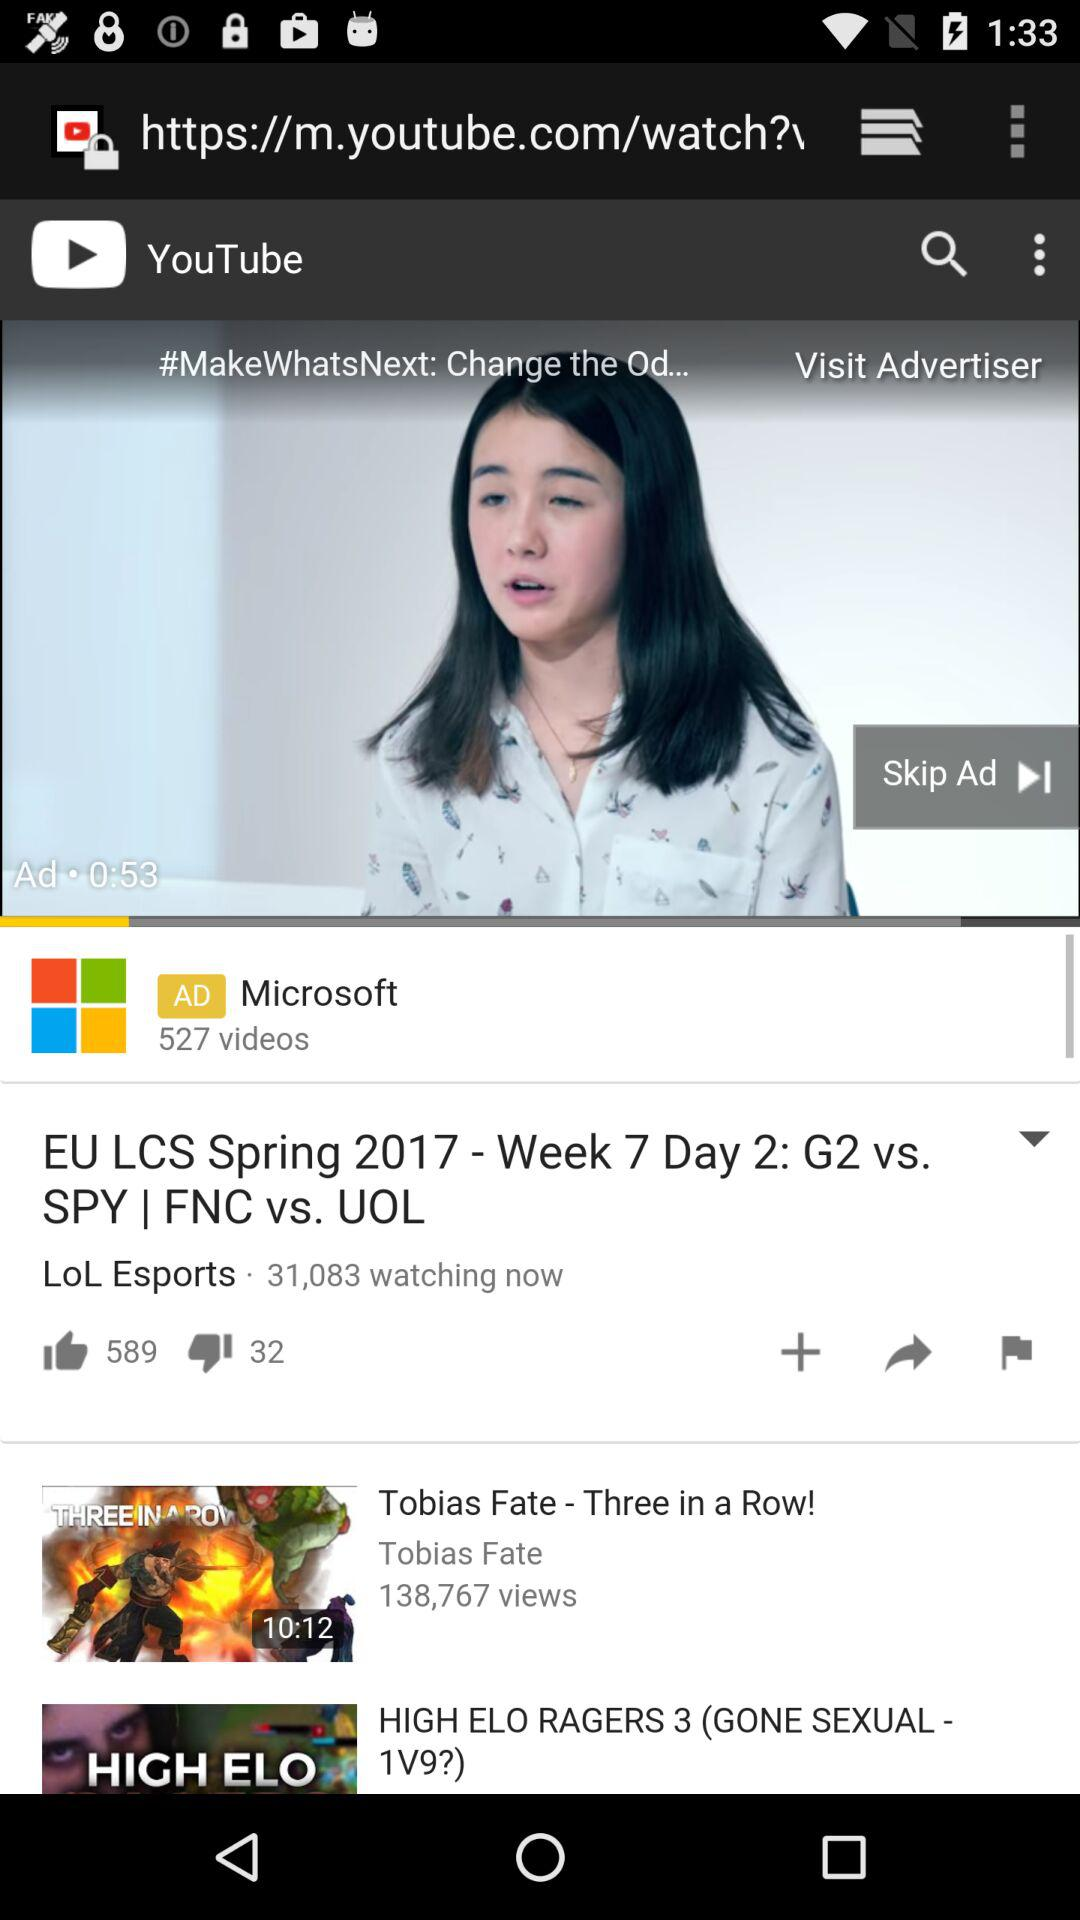How many likes and dislikes are there on the "EU LCS Spring 2017" video? There are 589 likes and 32 dislikes on the video. 